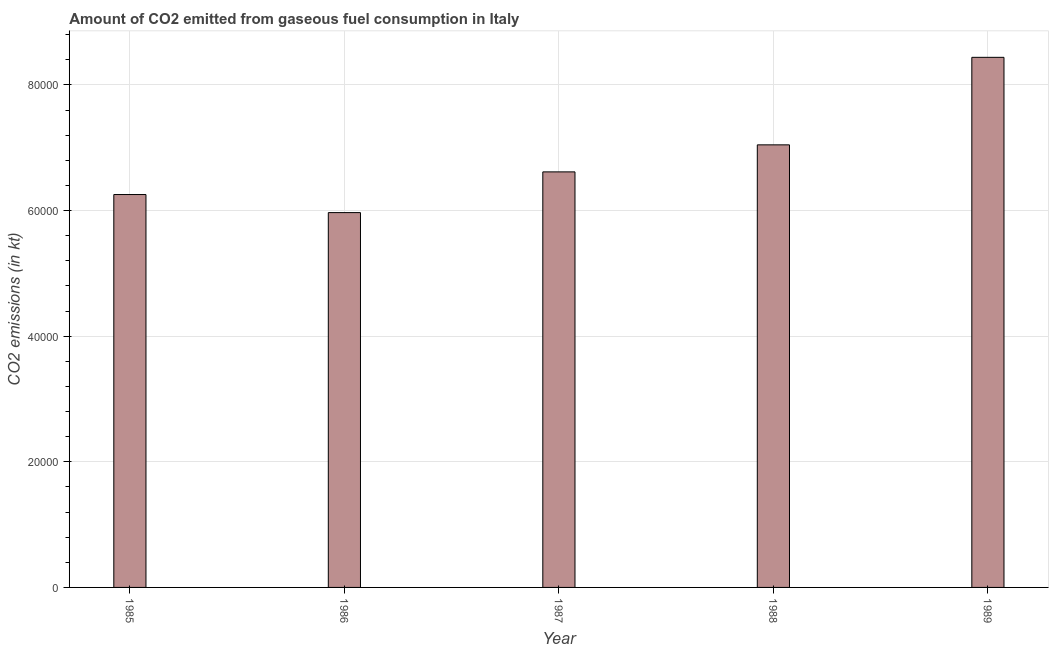Does the graph contain grids?
Make the answer very short. Yes. What is the title of the graph?
Your answer should be compact. Amount of CO2 emitted from gaseous fuel consumption in Italy. What is the label or title of the Y-axis?
Your response must be concise. CO2 emissions (in kt). What is the co2 emissions from gaseous fuel consumption in 1985?
Your answer should be very brief. 6.26e+04. Across all years, what is the maximum co2 emissions from gaseous fuel consumption?
Offer a very short reply. 8.44e+04. Across all years, what is the minimum co2 emissions from gaseous fuel consumption?
Ensure brevity in your answer.  5.97e+04. In which year was the co2 emissions from gaseous fuel consumption maximum?
Ensure brevity in your answer.  1989. What is the sum of the co2 emissions from gaseous fuel consumption?
Offer a terse response. 3.43e+05. What is the difference between the co2 emissions from gaseous fuel consumption in 1986 and 1989?
Your answer should be compact. -2.47e+04. What is the average co2 emissions from gaseous fuel consumption per year?
Give a very brief answer. 6.87e+04. What is the median co2 emissions from gaseous fuel consumption?
Your answer should be compact. 6.62e+04. In how many years, is the co2 emissions from gaseous fuel consumption greater than 32000 kt?
Ensure brevity in your answer.  5. What is the ratio of the co2 emissions from gaseous fuel consumption in 1988 to that in 1989?
Provide a short and direct response. 0.83. Is the co2 emissions from gaseous fuel consumption in 1986 less than that in 1988?
Keep it short and to the point. Yes. Is the difference between the co2 emissions from gaseous fuel consumption in 1986 and 1987 greater than the difference between any two years?
Give a very brief answer. No. What is the difference between the highest and the second highest co2 emissions from gaseous fuel consumption?
Provide a short and direct response. 1.39e+04. What is the difference between the highest and the lowest co2 emissions from gaseous fuel consumption?
Your answer should be compact. 2.47e+04. How many bars are there?
Ensure brevity in your answer.  5. Are all the bars in the graph horizontal?
Give a very brief answer. No. How many years are there in the graph?
Give a very brief answer. 5. What is the difference between two consecutive major ticks on the Y-axis?
Provide a short and direct response. 2.00e+04. What is the CO2 emissions (in kt) in 1985?
Provide a succinct answer. 6.26e+04. What is the CO2 emissions (in kt) of 1986?
Your response must be concise. 5.97e+04. What is the CO2 emissions (in kt) in 1987?
Offer a terse response. 6.62e+04. What is the CO2 emissions (in kt) of 1988?
Give a very brief answer. 7.05e+04. What is the CO2 emissions (in kt) of 1989?
Provide a short and direct response. 8.44e+04. What is the difference between the CO2 emissions (in kt) in 1985 and 1986?
Ensure brevity in your answer.  2874.93. What is the difference between the CO2 emissions (in kt) in 1985 and 1987?
Offer a terse response. -3608.33. What is the difference between the CO2 emissions (in kt) in 1985 and 1988?
Offer a terse response. -7913.39. What is the difference between the CO2 emissions (in kt) in 1985 and 1989?
Your response must be concise. -2.18e+04. What is the difference between the CO2 emissions (in kt) in 1986 and 1987?
Your answer should be compact. -6483.26. What is the difference between the CO2 emissions (in kt) in 1986 and 1988?
Provide a short and direct response. -1.08e+04. What is the difference between the CO2 emissions (in kt) in 1986 and 1989?
Offer a terse response. -2.47e+04. What is the difference between the CO2 emissions (in kt) in 1987 and 1988?
Offer a terse response. -4305.06. What is the difference between the CO2 emissions (in kt) in 1987 and 1989?
Keep it short and to the point. -1.82e+04. What is the difference between the CO2 emissions (in kt) in 1988 and 1989?
Offer a very short reply. -1.39e+04. What is the ratio of the CO2 emissions (in kt) in 1985 to that in 1986?
Give a very brief answer. 1.05. What is the ratio of the CO2 emissions (in kt) in 1985 to that in 1987?
Ensure brevity in your answer.  0.94. What is the ratio of the CO2 emissions (in kt) in 1985 to that in 1988?
Keep it short and to the point. 0.89. What is the ratio of the CO2 emissions (in kt) in 1985 to that in 1989?
Offer a very short reply. 0.74. What is the ratio of the CO2 emissions (in kt) in 1986 to that in 1987?
Make the answer very short. 0.9. What is the ratio of the CO2 emissions (in kt) in 1986 to that in 1988?
Your response must be concise. 0.85. What is the ratio of the CO2 emissions (in kt) in 1986 to that in 1989?
Your answer should be compact. 0.71. What is the ratio of the CO2 emissions (in kt) in 1987 to that in 1988?
Give a very brief answer. 0.94. What is the ratio of the CO2 emissions (in kt) in 1987 to that in 1989?
Your answer should be compact. 0.78. What is the ratio of the CO2 emissions (in kt) in 1988 to that in 1989?
Keep it short and to the point. 0.83. 